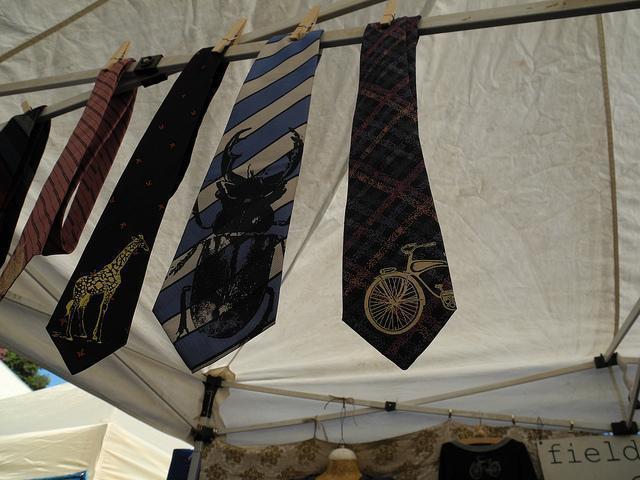How many ties are there?
Give a very brief answer. 5. How many ties are in the picture?
Give a very brief answer. 5. 